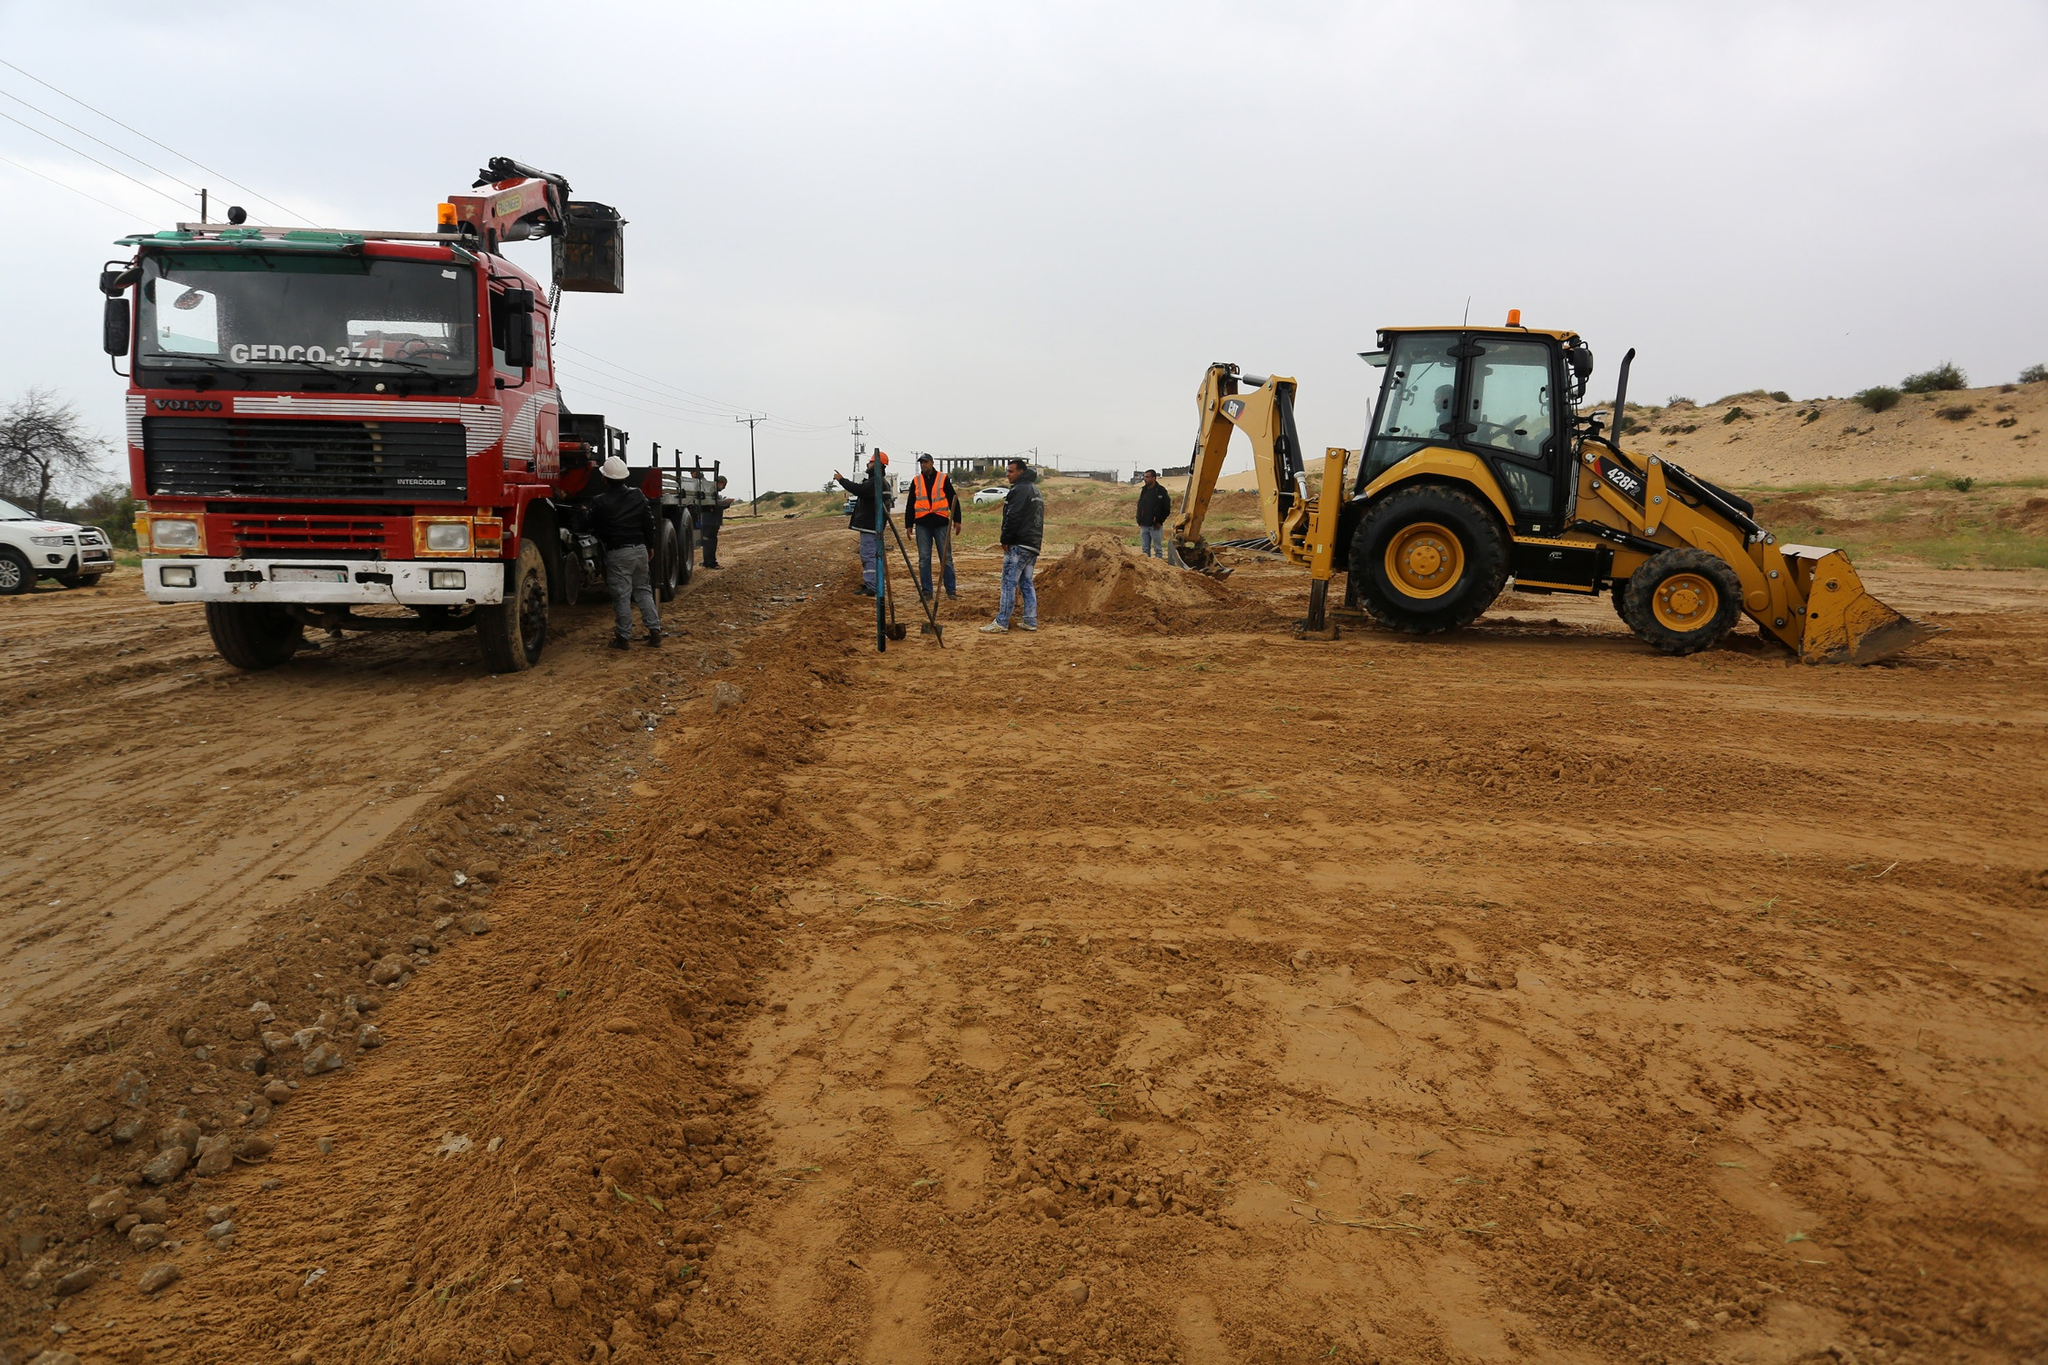What do you think is going on in this snapshot? The image captures a lively construction site filled with activity. A prominent red and white truck, equipped with a crane, is parked on the left, indicating its role in heavy lifting and moving materials. Opposite, a yellow bulldozer stands ready for use, its shovel attached and poised to work the soil. The dirt-covered ground is filled with tire tracks, clearly marking the pathway of the machinery. Several workers, dressed in construction gear, are visible, discussing plans and coordinating tasks, adding a human touch to the industrial setting. The overcast sky casts a soft, diffuse light, setting a somewhat somber yet productive mood for the ongoing work. Overall, it’s a snapshot of teamwork and machinery working together to achieve their construction goal. 